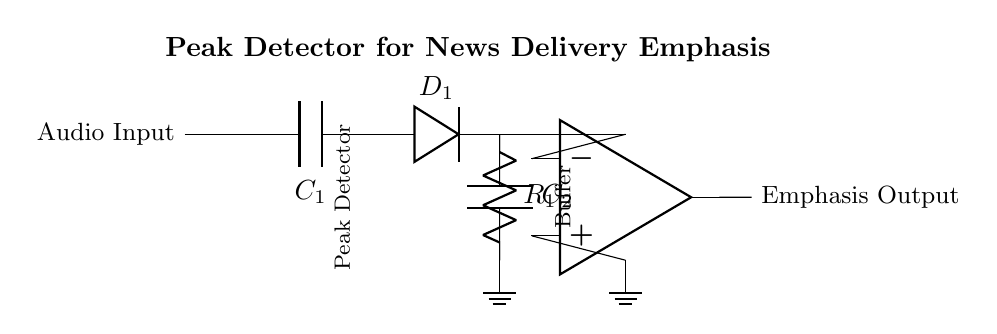What type of component is C1? The component C1 is a capacitor, which is shown in the circuit diagram and typically serves to block DC while allowing AC signals to pass through.
Answer: Capacitor What is the role of D1 in the circuit? D1 is a diode that allows current to flow in one direction only, enabling the peak detection function by charging the capacitor C2 during positive signal peaks and preventing it from discharging during negative cycles.
Answer: Peak detection What is the function of R1? R1 is a resistor that provides a discharge path for the capacitor C2, determining how quickly the capacitor discharges and thus affecting the response time of the peak detector.
Answer: Discharge How many operational amplifiers are present? There is one operational amplifier in the circuit, which is used to buffer the output signal from the peak detection stage, ensuring a strong impedance match and isolating the output from the input.
Answer: One What is the emphasis output? The emphasis output is the output signal after processing that indicates the detected peak of the audio input, which reflects the emphasis placed on certain audio events during news delivery.
Answer: Emphasis output What happens to the voltage across C2 during signal peaks? During signal peaks, the diode D1 conducts, allowing current to charge the capacitor C2 without discharging it, effectively capturing and storing the peak voltage level until it is released through R1.
Answer: Charges What is the observed direction of current flow through D1? The current flows from C1 towards C2 through D1, indicating that D1 is forward-biased during positive signal peaks, allowing the current to charge C2.
Answer: Forward 